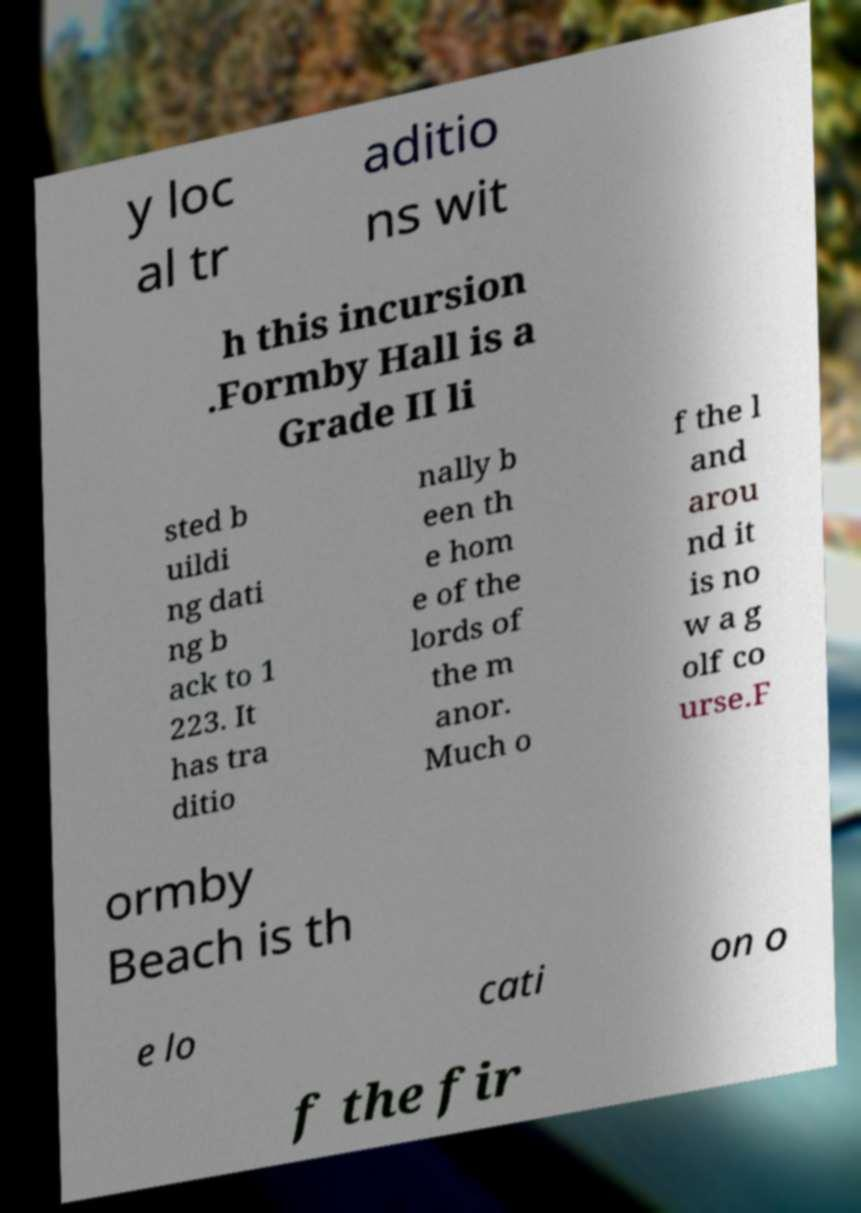Could you assist in decoding the text presented in this image and type it out clearly? y loc al tr aditio ns wit h this incursion .Formby Hall is a Grade II li sted b uildi ng dati ng b ack to 1 223. It has tra ditio nally b een th e hom e of the lords of the m anor. Much o f the l and arou nd it is no w a g olf co urse.F ormby Beach is th e lo cati on o f the fir 